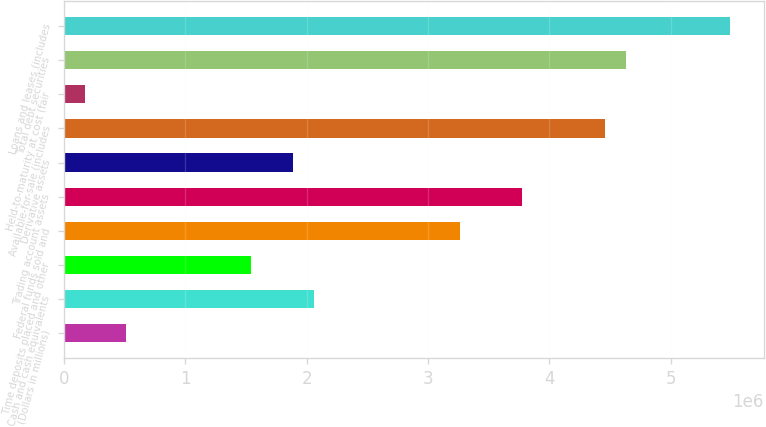<chart> <loc_0><loc_0><loc_500><loc_500><bar_chart><fcel>(Dollars in millions)<fcel>Cash and cash equivalents<fcel>Time deposits placed and other<fcel>Federal funds sold and<fcel>Trading account assets<fcel>Derivative assets<fcel>Available-for-sale (includes<fcel>Held-to-maturity at cost (fair<fcel>Total debt securities<fcel>Loans and leases (includes<nl><fcel>515043<fcel>2.0588e+06<fcel>1.54422e+06<fcel>3.25951e+06<fcel>3.77409e+06<fcel>1.88728e+06<fcel>4.46021e+06<fcel>171985<fcel>4.63174e+06<fcel>5.48938e+06<nl></chart> 